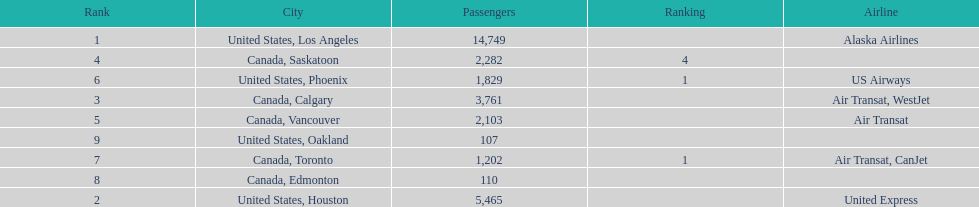Can you give me this table as a dict? {'header': ['Rank', 'City', 'Passengers', 'Ranking', 'Airline'], 'rows': [['1', 'United States, Los Angeles', '14,749', '', 'Alaska Airlines'], ['4', 'Canada, Saskatoon', '2,282', '4', ''], ['6', 'United States, Phoenix', '1,829', '1', 'US Airways'], ['3', 'Canada, Calgary', '3,761', '', 'Air Transat, WestJet'], ['5', 'Canada, Vancouver', '2,103', '', 'Air Transat'], ['9', 'United States, Oakland', '107', '', ''], ['7', 'Canada, Toronto', '1,202', '1', 'Air Transat, CanJet'], ['8', 'Canada, Edmonton', '110', '', ''], ['2', 'United States, Houston', '5,465', '', 'United Express']]} Was los angeles or houston the busiest international route at manzanillo international airport in 2013? Los Angeles. 